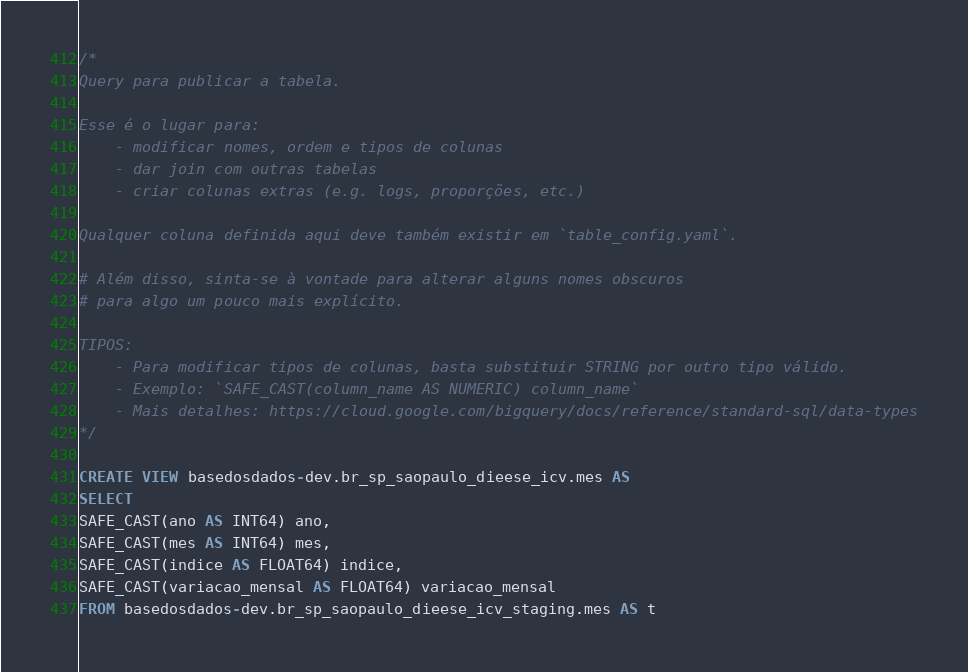Convert code to text. <code><loc_0><loc_0><loc_500><loc_500><_SQL_>/*
Query para publicar a tabela.

Esse é o lugar para:
    - modificar nomes, ordem e tipos de colunas
    - dar join com outras tabelas
    - criar colunas extras (e.g. logs, proporções, etc.)

Qualquer coluna definida aqui deve também existir em `table_config.yaml`.

# Além disso, sinta-se à vontade para alterar alguns nomes obscuros
# para algo um pouco mais explícito.

TIPOS:
    - Para modificar tipos de colunas, basta substituir STRING por outro tipo válido.
    - Exemplo: `SAFE_CAST(column_name AS NUMERIC) column_name`
    - Mais detalhes: https://cloud.google.com/bigquery/docs/reference/standard-sql/data-types
*/

CREATE VIEW basedosdados-dev.br_sp_saopaulo_dieese_icv.mes AS
SELECT 
SAFE_CAST(ano AS INT64) ano,
SAFE_CAST(mes AS INT64) mes,
SAFE_CAST(indice AS FLOAT64) indice,
SAFE_CAST(variacao_mensal AS FLOAT64) variacao_mensal
FROM basedosdados-dev.br_sp_saopaulo_dieese_icv_staging.mes AS t</code> 